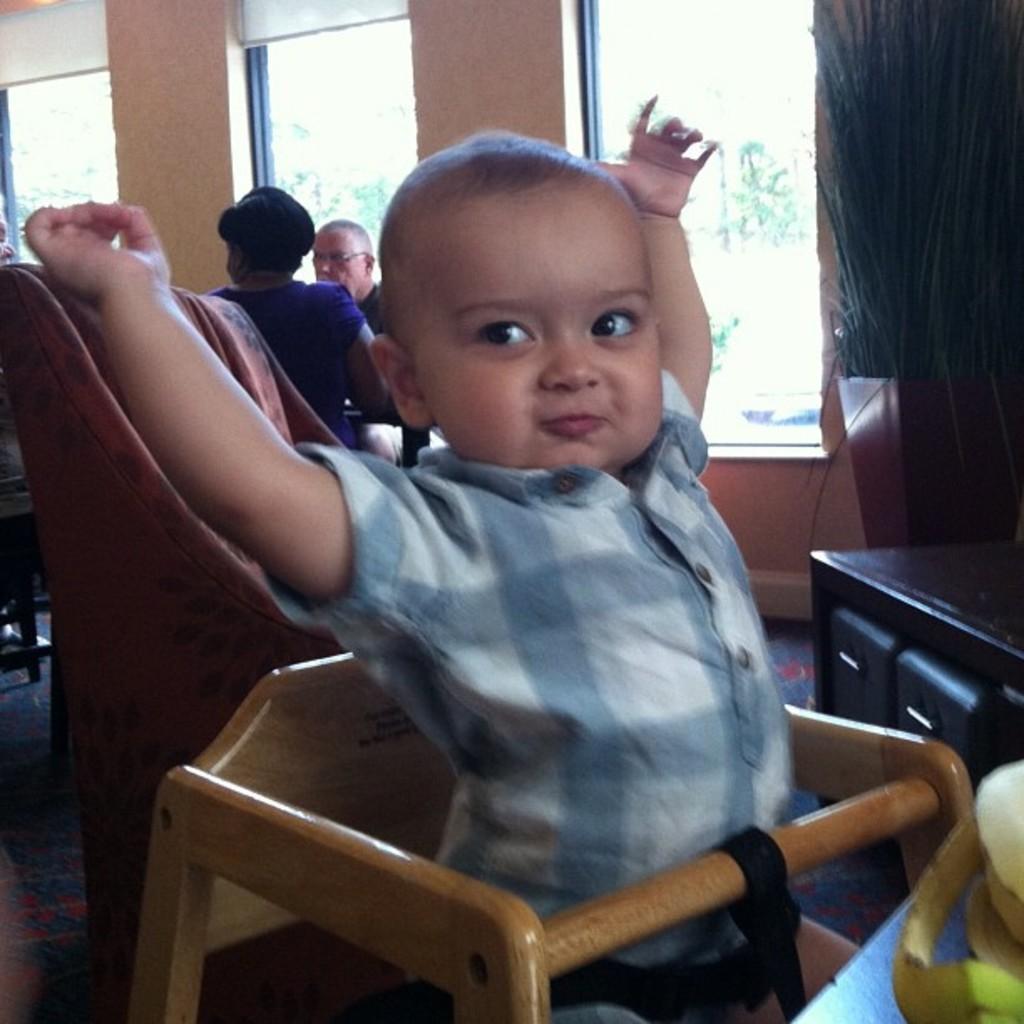In one or two sentences, can you explain what this image depicts? This image consists of a kid sitting in a chair. In the background, there are two persons sitting. At the bottom, there is a floor. In the background, there are windows. On the right, there is a cabinet. 